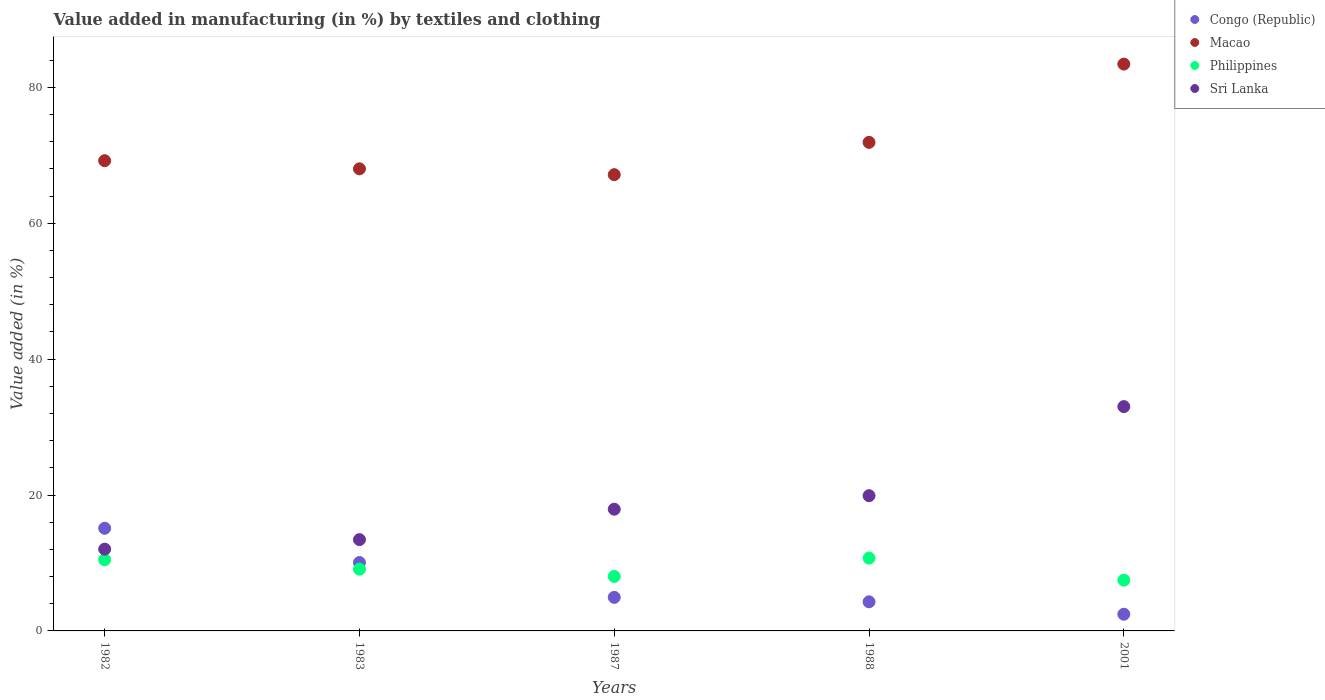Is the number of dotlines equal to the number of legend labels?
Make the answer very short. Yes. What is the percentage of value added in manufacturing by textiles and clothing in Macao in 1988?
Keep it short and to the point. 71.9. Across all years, what is the maximum percentage of value added in manufacturing by textiles and clothing in Sri Lanka?
Keep it short and to the point. 33.01. Across all years, what is the minimum percentage of value added in manufacturing by textiles and clothing in Sri Lanka?
Give a very brief answer. 12.04. In which year was the percentage of value added in manufacturing by textiles and clothing in Congo (Republic) maximum?
Offer a very short reply. 1982. What is the total percentage of value added in manufacturing by textiles and clothing in Macao in the graph?
Ensure brevity in your answer.  359.7. What is the difference between the percentage of value added in manufacturing by textiles and clothing in Philippines in 1983 and that in 2001?
Keep it short and to the point. 1.62. What is the difference between the percentage of value added in manufacturing by textiles and clothing in Congo (Republic) in 1988 and the percentage of value added in manufacturing by textiles and clothing in Philippines in 2001?
Give a very brief answer. -3.19. What is the average percentage of value added in manufacturing by textiles and clothing in Sri Lanka per year?
Keep it short and to the point. 19.26. In the year 1983, what is the difference between the percentage of value added in manufacturing by textiles and clothing in Sri Lanka and percentage of value added in manufacturing by textiles and clothing in Congo (Republic)?
Keep it short and to the point. 3.37. In how many years, is the percentage of value added in manufacturing by textiles and clothing in Sri Lanka greater than 8 %?
Ensure brevity in your answer.  5. What is the ratio of the percentage of value added in manufacturing by textiles and clothing in Macao in 1987 to that in 1988?
Make the answer very short. 0.93. What is the difference between the highest and the second highest percentage of value added in manufacturing by textiles and clothing in Macao?
Offer a very short reply. 11.52. What is the difference between the highest and the lowest percentage of value added in manufacturing by textiles and clothing in Congo (Republic)?
Make the answer very short. 12.65. In how many years, is the percentage of value added in manufacturing by textiles and clothing in Macao greater than the average percentage of value added in manufacturing by textiles and clothing in Macao taken over all years?
Your response must be concise. 1. Is it the case that in every year, the sum of the percentage of value added in manufacturing by textiles and clothing in Congo (Republic) and percentage of value added in manufacturing by textiles and clothing in Macao  is greater than the percentage of value added in manufacturing by textiles and clothing in Sri Lanka?
Ensure brevity in your answer.  Yes. How many years are there in the graph?
Offer a very short reply. 5. What is the difference between two consecutive major ticks on the Y-axis?
Keep it short and to the point. 20. Does the graph contain any zero values?
Your answer should be compact. No. Does the graph contain grids?
Your response must be concise. No. Where does the legend appear in the graph?
Keep it short and to the point. Top right. What is the title of the graph?
Make the answer very short. Value added in manufacturing (in %) by textiles and clothing. What is the label or title of the X-axis?
Give a very brief answer. Years. What is the label or title of the Y-axis?
Ensure brevity in your answer.  Value added (in %). What is the Value added (in %) in Congo (Republic) in 1982?
Your response must be concise. 15.11. What is the Value added (in %) of Macao in 1982?
Your answer should be compact. 69.21. What is the Value added (in %) in Philippines in 1982?
Give a very brief answer. 10.48. What is the Value added (in %) in Sri Lanka in 1982?
Offer a terse response. 12.04. What is the Value added (in %) of Congo (Republic) in 1983?
Provide a short and direct response. 10.07. What is the Value added (in %) of Macao in 1983?
Offer a terse response. 68.01. What is the Value added (in %) in Philippines in 1983?
Offer a very short reply. 9.1. What is the Value added (in %) in Sri Lanka in 1983?
Provide a succinct answer. 13.44. What is the Value added (in %) of Congo (Republic) in 1987?
Make the answer very short. 4.94. What is the Value added (in %) in Macao in 1987?
Offer a terse response. 67.15. What is the Value added (in %) of Philippines in 1987?
Your answer should be compact. 8.02. What is the Value added (in %) in Sri Lanka in 1987?
Offer a terse response. 17.91. What is the Value added (in %) in Congo (Republic) in 1988?
Your answer should be compact. 4.28. What is the Value added (in %) in Macao in 1988?
Make the answer very short. 71.9. What is the Value added (in %) in Philippines in 1988?
Give a very brief answer. 10.72. What is the Value added (in %) of Sri Lanka in 1988?
Your answer should be compact. 19.9. What is the Value added (in %) of Congo (Republic) in 2001?
Provide a succinct answer. 2.46. What is the Value added (in %) of Macao in 2001?
Provide a short and direct response. 83.43. What is the Value added (in %) in Philippines in 2001?
Provide a short and direct response. 7.47. What is the Value added (in %) in Sri Lanka in 2001?
Make the answer very short. 33.01. Across all years, what is the maximum Value added (in %) in Congo (Republic)?
Ensure brevity in your answer.  15.11. Across all years, what is the maximum Value added (in %) in Macao?
Give a very brief answer. 83.43. Across all years, what is the maximum Value added (in %) of Philippines?
Offer a terse response. 10.72. Across all years, what is the maximum Value added (in %) of Sri Lanka?
Your answer should be very brief. 33.01. Across all years, what is the minimum Value added (in %) of Congo (Republic)?
Ensure brevity in your answer.  2.46. Across all years, what is the minimum Value added (in %) of Macao?
Give a very brief answer. 67.15. Across all years, what is the minimum Value added (in %) in Philippines?
Provide a short and direct response. 7.47. Across all years, what is the minimum Value added (in %) in Sri Lanka?
Keep it short and to the point. 12.04. What is the total Value added (in %) of Congo (Republic) in the graph?
Give a very brief answer. 36.86. What is the total Value added (in %) in Macao in the graph?
Offer a very short reply. 359.7. What is the total Value added (in %) of Philippines in the graph?
Offer a terse response. 45.79. What is the total Value added (in %) in Sri Lanka in the graph?
Provide a succinct answer. 96.31. What is the difference between the Value added (in %) of Congo (Republic) in 1982 and that in 1983?
Give a very brief answer. 5.04. What is the difference between the Value added (in %) of Macao in 1982 and that in 1983?
Provide a succinct answer. 1.2. What is the difference between the Value added (in %) of Philippines in 1982 and that in 1983?
Make the answer very short. 1.39. What is the difference between the Value added (in %) in Sri Lanka in 1982 and that in 1983?
Provide a short and direct response. -1.4. What is the difference between the Value added (in %) of Congo (Republic) in 1982 and that in 1987?
Provide a short and direct response. 10.17. What is the difference between the Value added (in %) in Macao in 1982 and that in 1987?
Offer a terse response. 2.06. What is the difference between the Value added (in %) of Philippines in 1982 and that in 1987?
Keep it short and to the point. 2.46. What is the difference between the Value added (in %) of Sri Lanka in 1982 and that in 1987?
Your answer should be very brief. -5.88. What is the difference between the Value added (in %) in Congo (Republic) in 1982 and that in 1988?
Keep it short and to the point. 10.82. What is the difference between the Value added (in %) of Macao in 1982 and that in 1988?
Ensure brevity in your answer.  -2.7. What is the difference between the Value added (in %) of Philippines in 1982 and that in 1988?
Keep it short and to the point. -0.23. What is the difference between the Value added (in %) of Sri Lanka in 1982 and that in 1988?
Your response must be concise. -7.87. What is the difference between the Value added (in %) in Congo (Republic) in 1982 and that in 2001?
Make the answer very short. 12.65. What is the difference between the Value added (in %) in Macao in 1982 and that in 2001?
Offer a very short reply. -14.22. What is the difference between the Value added (in %) in Philippines in 1982 and that in 2001?
Your response must be concise. 3.01. What is the difference between the Value added (in %) of Sri Lanka in 1982 and that in 2001?
Make the answer very short. -20.98. What is the difference between the Value added (in %) of Congo (Republic) in 1983 and that in 1987?
Make the answer very short. 5.13. What is the difference between the Value added (in %) of Macao in 1983 and that in 1987?
Keep it short and to the point. 0.86. What is the difference between the Value added (in %) in Philippines in 1983 and that in 1987?
Keep it short and to the point. 1.07. What is the difference between the Value added (in %) of Sri Lanka in 1983 and that in 1987?
Ensure brevity in your answer.  -4.48. What is the difference between the Value added (in %) in Congo (Republic) in 1983 and that in 1988?
Provide a short and direct response. 5.78. What is the difference between the Value added (in %) of Macao in 1983 and that in 1988?
Ensure brevity in your answer.  -3.89. What is the difference between the Value added (in %) in Philippines in 1983 and that in 1988?
Your response must be concise. -1.62. What is the difference between the Value added (in %) in Sri Lanka in 1983 and that in 1988?
Your response must be concise. -6.47. What is the difference between the Value added (in %) in Congo (Republic) in 1983 and that in 2001?
Your answer should be compact. 7.61. What is the difference between the Value added (in %) of Macao in 1983 and that in 2001?
Provide a short and direct response. -15.41. What is the difference between the Value added (in %) in Philippines in 1983 and that in 2001?
Provide a succinct answer. 1.62. What is the difference between the Value added (in %) in Sri Lanka in 1983 and that in 2001?
Make the answer very short. -19.58. What is the difference between the Value added (in %) in Congo (Republic) in 1987 and that in 1988?
Provide a succinct answer. 0.66. What is the difference between the Value added (in %) of Macao in 1987 and that in 1988?
Offer a terse response. -4.75. What is the difference between the Value added (in %) of Philippines in 1987 and that in 1988?
Offer a very short reply. -2.7. What is the difference between the Value added (in %) of Sri Lanka in 1987 and that in 1988?
Make the answer very short. -1.99. What is the difference between the Value added (in %) of Congo (Republic) in 1987 and that in 2001?
Provide a short and direct response. 2.48. What is the difference between the Value added (in %) in Macao in 1987 and that in 2001?
Your answer should be very brief. -16.28. What is the difference between the Value added (in %) in Philippines in 1987 and that in 2001?
Provide a succinct answer. 0.55. What is the difference between the Value added (in %) of Sri Lanka in 1987 and that in 2001?
Your answer should be compact. -15.1. What is the difference between the Value added (in %) in Congo (Republic) in 1988 and that in 2001?
Make the answer very short. 1.83. What is the difference between the Value added (in %) in Macao in 1988 and that in 2001?
Keep it short and to the point. -11.52. What is the difference between the Value added (in %) of Philippines in 1988 and that in 2001?
Your answer should be very brief. 3.24. What is the difference between the Value added (in %) in Sri Lanka in 1988 and that in 2001?
Your response must be concise. -13.11. What is the difference between the Value added (in %) in Congo (Republic) in 1982 and the Value added (in %) in Macao in 1983?
Provide a succinct answer. -52.9. What is the difference between the Value added (in %) of Congo (Republic) in 1982 and the Value added (in %) of Philippines in 1983?
Keep it short and to the point. 6.01. What is the difference between the Value added (in %) in Congo (Republic) in 1982 and the Value added (in %) in Sri Lanka in 1983?
Your answer should be compact. 1.67. What is the difference between the Value added (in %) of Macao in 1982 and the Value added (in %) of Philippines in 1983?
Give a very brief answer. 60.11. What is the difference between the Value added (in %) of Macao in 1982 and the Value added (in %) of Sri Lanka in 1983?
Give a very brief answer. 55.77. What is the difference between the Value added (in %) in Philippines in 1982 and the Value added (in %) in Sri Lanka in 1983?
Keep it short and to the point. -2.95. What is the difference between the Value added (in %) of Congo (Republic) in 1982 and the Value added (in %) of Macao in 1987?
Make the answer very short. -52.04. What is the difference between the Value added (in %) of Congo (Republic) in 1982 and the Value added (in %) of Philippines in 1987?
Give a very brief answer. 7.08. What is the difference between the Value added (in %) of Congo (Republic) in 1982 and the Value added (in %) of Sri Lanka in 1987?
Provide a short and direct response. -2.81. What is the difference between the Value added (in %) in Macao in 1982 and the Value added (in %) in Philippines in 1987?
Offer a very short reply. 61.19. What is the difference between the Value added (in %) of Macao in 1982 and the Value added (in %) of Sri Lanka in 1987?
Provide a succinct answer. 51.29. What is the difference between the Value added (in %) of Philippines in 1982 and the Value added (in %) of Sri Lanka in 1987?
Provide a succinct answer. -7.43. What is the difference between the Value added (in %) in Congo (Republic) in 1982 and the Value added (in %) in Macao in 1988?
Give a very brief answer. -56.8. What is the difference between the Value added (in %) of Congo (Republic) in 1982 and the Value added (in %) of Philippines in 1988?
Give a very brief answer. 4.39. What is the difference between the Value added (in %) in Congo (Republic) in 1982 and the Value added (in %) in Sri Lanka in 1988?
Offer a terse response. -4.8. What is the difference between the Value added (in %) in Macao in 1982 and the Value added (in %) in Philippines in 1988?
Offer a terse response. 58.49. What is the difference between the Value added (in %) of Macao in 1982 and the Value added (in %) of Sri Lanka in 1988?
Your answer should be compact. 49.3. What is the difference between the Value added (in %) of Philippines in 1982 and the Value added (in %) of Sri Lanka in 1988?
Your answer should be very brief. -9.42. What is the difference between the Value added (in %) of Congo (Republic) in 1982 and the Value added (in %) of Macao in 2001?
Ensure brevity in your answer.  -68.32. What is the difference between the Value added (in %) in Congo (Republic) in 1982 and the Value added (in %) in Philippines in 2001?
Provide a succinct answer. 7.63. What is the difference between the Value added (in %) in Congo (Republic) in 1982 and the Value added (in %) in Sri Lanka in 2001?
Your answer should be compact. -17.91. What is the difference between the Value added (in %) of Macao in 1982 and the Value added (in %) of Philippines in 2001?
Offer a very short reply. 61.73. What is the difference between the Value added (in %) in Macao in 1982 and the Value added (in %) in Sri Lanka in 2001?
Ensure brevity in your answer.  36.19. What is the difference between the Value added (in %) in Philippines in 1982 and the Value added (in %) in Sri Lanka in 2001?
Your response must be concise. -22.53. What is the difference between the Value added (in %) of Congo (Republic) in 1983 and the Value added (in %) of Macao in 1987?
Keep it short and to the point. -57.08. What is the difference between the Value added (in %) of Congo (Republic) in 1983 and the Value added (in %) of Philippines in 1987?
Give a very brief answer. 2.04. What is the difference between the Value added (in %) in Congo (Republic) in 1983 and the Value added (in %) in Sri Lanka in 1987?
Provide a short and direct response. -7.85. What is the difference between the Value added (in %) of Macao in 1983 and the Value added (in %) of Philippines in 1987?
Ensure brevity in your answer.  59.99. What is the difference between the Value added (in %) in Macao in 1983 and the Value added (in %) in Sri Lanka in 1987?
Your response must be concise. 50.1. What is the difference between the Value added (in %) in Philippines in 1983 and the Value added (in %) in Sri Lanka in 1987?
Provide a short and direct response. -8.82. What is the difference between the Value added (in %) in Congo (Republic) in 1983 and the Value added (in %) in Macao in 1988?
Provide a succinct answer. -61.84. What is the difference between the Value added (in %) in Congo (Republic) in 1983 and the Value added (in %) in Philippines in 1988?
Provide a short and direct response. -0.65. What is the difference between the Value added (in %) of Congo (Republic) in 1983 and the Value added (in %) of Sri Lanka in 1988?
Give a very brief answer. -9.84. What is the difference between the Value added (in %) of Macao in 1983 and the Value added (in %) of Philippines in 1988?
Provide a succinct answer. 57.29. What is the difference between the Value added (in %) in Macao in 1983 and the Value added (in %) in Sri Lanka in 1988?
Make the answer very short. 48.11. What is the difference between the Value added (in %) in Philippines in 1983 and the Value added (in %) in Sri Lanka in 1988?
Your response must be concise. -10.81. What is the difference between the Value added (in %) in Congo (Republic) in 1983 and the Value added (in %) in Macao in 2001?
Give a very brief answer. -73.36. What is the difference between the Value added (in %) of Congo (Republic) in 1983 and the Value added (in %) of Philippines in 2001?
Offer a terse response. 2.59. What is the difference between the Value added (in %) of Congo (Republic) in 1983 and the Value added (in %) of Sri Lanka in 2001?
Give a very brief answer. -22.95. What is the difference between the Value added (in %) in Macao in 1983 and the Value added (in %) in Philippines in 2001?
Your answer should be compact. 60.54. What is the difference between the Value added (in %) of Macao in 1983 and the Value added (in %) of Sri Lanka in 2001?
Provide a short and direct response. 35. What is the difference between the Value added (in %) of Philippines in 1983 and the Value added (in %) of Sri Lanka in 2001?
Make the answer very short. -23.92. What is the difference between the Value added (in %) in Congo (Republic) in 1987 and the Value added (in %) in Macao in 1988?
Make the answer very short. -66.96. What is the difference between the Value added (in %) of Congo (Republic) in 1987 and the Value added (in %) of Philippines in 1988?
Offer a very short reply. -5.78. What is the difference between the Value added (in %) of Congo (Republic) in 1987 and the Value added (in %) of Sri Lanka in 1988?
Your answer should be very brief. -14.96. What is the difference between the Value added (in %) of Macao in 1987 and the Value added (in %) of Philippines in 1988?
Keep it short and to the point. 56.43. What is the difference between the Value added (in %) in Macao in 1987 and the Value added (in %) in Sri Lanka in 1988?
Provide a succinct answer. 47.25. What is the difference between the Value added (in %) of Philippines in 1987 and the Value added (in %) of Sri Lanka in 1988?
Your response must be concise. -11.88. What is the difference between the Value added (in %) in Congo (Republic) in 1987 and the Value added (in %) in Macao in 2001?
Keep it short and to the point. -78.49. What is the difference between the Value added (in %) in Congo (Republic) in 1987 and the Value added (in %) in Philippines in 2001?
Offer a terse response. -2.53. What is the difference between the Value added (in %) of Congo (Republic) in 1987 and the Value added (in %) of Sri Lanka in 2001?
Give a very brief answer. -28.07. What is the difference between the Value added (in %) of Macao in 1987 and the Value added (in %) of Philippines in 2001?
Your answer should be very brief. 59.68. What is the difference between the Value added (in %) of Macao in 1987 and the Value added (in %) of Sri Lanka in 2001?
Provide a short and direct response. 34.14. What is the difference between the Value added (in %) in Philippines in 1987 and the Value added (in %) in Sri Lanka in 2001?
Give a very brief answer. -24.99. What is the difference between the Value added (in %) of Congo (Republic) in 1988 and the Value added (in %) of Macao in 2001?
Give a very brief answer. -79.14. What is the difference between the Value added (in %) of Congo (Republic) in 1988 and the Value added (in %) of Philippines in 2001?
Give a very brief answer. -3.19. What is the difference between the Value added (in %) in Congo (Republic) in 1988 and the Value added (in %) in Sri Lanka in 2001?
Keep it short and to the point. -28.73. What is the difference between the Value added (in %) of Macao in 1988 and the Value added (in %) of Philippines in 2001?
Make the answer very short. 64.43. What is the difference between the Value added (in %) in Macao in 1988 and the Value added (in %) in Sri Lanka in 2001?
Provide a short and direct response. 38.89. What is the difference between the Value added (in %) in Philippines in 1988 and the Value added (in %) in Sri Lanka in 2001?
Your answer should be very brief. -22.3. What is the average Value added (in %) in Congo (Republic) per year?
Your response must be concise. 7.37. What is the average Value added (in %) in Macao per year?
Your answer should be compact. 71.94. What is the average Value added (in %) of Philippines per year?
Keep it short and to the point. 9.16. What is the average Value added (in %) in Sri Lanka per year?
Give a very brief answer. 19.26. In the year 1982, what is the difference between the Value added (in %) of Congo (Republic) and Value added (in %) of Macao?
Provide a succinct answer. -54.1. In the year 1982, what is the difference between the Value added (in %) of Congo (Republic) and Value added (in %) of Philippines?
Make the answer very short. 4.62. In the year 1982, what is the difference between the Value added (in %) of Congo (Republic) and Value added (in %) of Sri Lanka?
Ensure brevity in your answer.  3.07. In the year 1982, what is the difference between the Value added (in %) in Macao and Value added (in %) in Philippines?
Your answer should be very brief. 58.72. In the year 1982, what is the difference between the Value added (in %) in Macao and Value added (in %) in Sri Lanka?
Provide a succinct answer. 57.17. In the year 1982, what is the difference between the Value added (in %) of Philippines and Value added (in %) of Sri Lanka?
Make the answer very short. -1.55. In the year 1983, what is the difference between the Value added (in %) of Congo (Republic) and Value added (in %) of Macao?
Give a very brief answer. -57.94. In the year 1983, what is the difference between the Value added (in %) in Congo (Republic) and Value added (in %) in Philippines?
Make the answer very short. 0.97. In the year 1983, what is the difference between the Value added (in %) of Congo (Republic) and Value added (in %) of Sri Lanka?
Provide a short and direct response. -3.37. In the year 1983, what is the difference between the Value added (in %) in Macao and Value added (in %) in Philippines?
Your answer should be compact. 58.91. In the year 1983, what is the difference between the Value added (in %) in Macao and Value added (in %) in Sri Lanka?
Provide a short and direct response. 54.57. In the year 1983, what is the difference between the Value added (in %) in Philippines and Value added (in %) in Sri Lanka?
Your response must be concise. -4.34. In the year 1987, what is the difference between the Value added (in %) of Congo (Republic) and Value added (in %) of Macao?
Offer a very short reply. -62.21. In the year 1987, what is the difference between the Value added (in %) of Congo (Republic) and Value added (in %) of Philippines?
Offer a terse response. -3.08. In the year 1987, what is the difference between the Value added (in %) of Congo (Republic) and Value added (in %) of Sri Lanka?
Your answer should be very brief. -12.97. In the year 1987, what is the difference between the Value added (in %) of Macao and Value added (in %) of Philippines?
Give a very brief answer. 59.13. In the year 1987, what is the difference between the Value added (in %) in Macao and Value added (in %) in Sri Lanka?
Give a very brief answer. 49.24. In the year 1987, what is the difference between the Value added (in %) in Philippines and Value added (in %) in Sri Lanka?
Your answer should be compact. -9.89. In the year 1988, what is the difference between the Value added (in %) in Congo (Republic) and Value added (in %) in Macao?
Make the answer very short. -67.62. In the year 1988, what is the difference between the Value added (in %) of Congo (Republic) and Value added (in %) of Philippines?
Offer a terse response. -6.43. In the year 1988, what is the difference between the Value added (in %) of Congo (Republic) and Value added (in %) of Sri Lanka?
Your answer should be very brief. -15.62. In the year 1988, what is the difference between the Value added (in %) of Macao and Value added (in %) of Philippines?
Offer a terse response. 61.19. In the year 1988, what is the difference between the Value added (in %) of Macao and Value added (in %) of Sri Lanka?
Offer a terse response. 52. In the year 1988, what is the difference between the Value added (in %) of Philippines and Value added (in %) of Sri Lanka?
Offer a terse response. -9.19. In the year 2001, what is the difference between the Value added (in %) in Congo (Republic) and Value added (in %) in Macao?
Give a very brief answer. -80.97. In the year 2001, what is the difference between the Value added (in %) in Congo (Republic) and Value added (in %) in Philippines?
Your answer should be very brief. -5.01. In the year 2001, what is the difference between the Value added (in %) of Congo (Republic) and Value added (in %) of Sri Lanka?
Offer a very short reply. -30.56. In the year 2001, what is the difference between the Value added (in %) in Macao and Value added (in %) in Philippines?
Offer a terse response. 75.95. In the year 2001, what is the difference between the Value added (in %) of Macao and Value added (in %) of Sri Lanka?
Your response must be concise. 50.41. In the year 2001, what is the difference between the Value added (in %) of Philippines and Value added (in %) of Sri Lanka?
Your answer should be compact. -25.54. What is the ratio of the Value added (in %) of Congo (Republic) in 1982 to that in 1983?
Provide a short and direct response. 1.5. What is the ratio of the Value added (in %) in Macao in 1982 to that in 1983?
Provide a succinct answer. 1.02. What is the ratio of the Value added (in %) in Philippines in 1982 to that in 1983?
Make the answer very short. 1.15. What is the ratio of the Value added (in %) of Sri Lanka in 1982 to that in 1983?
Make the answer very short. 0.9. What is the ratio of the Value added (in %) of Congo (Republic) in 1982 to that in 1987?
Give a very brief answer. 3.06. What is the ratio of the Value added (in %) of Macao in 1982 to that in 1987?
Provide a short and direct response. 1.03. What is the ratio of the Value added (in %) in Philippines in 1982 to that in 1987?
Make the answer very short. 1.31. What is the ratio of the Value added (in %) of Sri Lanka in 1982 to that in 1987?
Offer a very short reply. 0.67. What is the ratio of the Value added (in %) of Congo (Republic) in 1982 to that in 1988?
Offer a very short reply. 3.53. What is the ratio of the Value added (in %) in Macao in 1982 to that in 1988?
Your answer should be very brief. 0.96. What is the ratio of the Value added (in %) in Philippines in 1982 to that in 1988?
Keep it short and to the point. 0.98. What is the ratio of the Value added (in %) in Sri Lanka in 1982 to that in 1988?
Your answer should be compact. 0.6. What is the ratio of the Value added (in %) in Congo (Republic) in 1982 to that in 2001?
Your response must be concise. 6.15. What is the ratio of the Value added (in %) in Macao in 1982 to that in 2001?
Your answer should be very brief. 0.83. What is the ratio of the Value added (in %) in Philippines in 1982 to that in 2001?
Provide a short and direct response. 1.4. What is the ratio of the Value added (in %) in Sri Lanka in 1982 to that in 2001?
Your answer should be very brief. 0.36. What is the ratio of the Value added (in %) in Congo (Republic) in 1983 to that in 1987?
Offer a very short reply. 2.04. What is the ratio of the Value added (in %) in Macao in 1983 to that in 1987?
Offer a very short reply. 1.01. What is the ratio of the Value added (in %) in Philippines in 1983 to that in 1987?
Provide a short and direct response. 1.13. What is the ratio of the Value added (in %) of Sri Lanka in 1983 to that in 1987?
Provide a short and direct response. 0.75. What is the ratio of the Value added (in %) in Congo (Republic) in 1983 to that in 1988?
Provide a short and direct response. 2.35. What is the ratio of the Value added (in %) in Macao in 1983 to that in 1988?
Ensure brevity in your answer.  0.95. What is the ratio of the Value added (in %) in Philippines in 1983 to that in 1988?
Offer a very short reply. 0.85. What is the ratio of the Value added (in %) in Sri Lanka in 1983 to that in 1988?
Offer a terse response. 0.68. What is the ratio of the Value added (in %) in Congo (Republic) in 1983 to that in 2001?
Give a very brief answer. 4.09. What is the ratio of the Value added (in %) in Macao in 1983 to that in 2001?
Offer a very short reply. 0.82. What is the ratio of the Value added (in %) in Philippines in 1983 to that in 2001?
Offer a very short reply. 1.22. What is the ratio of the Value added (in %) in Sri Lanka in 1983 to that in 2001?
Provide a succinct answer. 0.41. What is the ratio of the Value added (in %) in Congo (Republic) in 1987 to that in 1988?
Keep it short and to the point. 1.15. What is the ratio of the Value added (in %) in Macao in 1987 to that in 1988?
Your answer should be very brief. 0.93. What is the ratio of the Value added (in %) in Philippines in 1987 to that in 1988?
Your answer should be compact. 0.75. What is the ratio of the Value added (in %) in Congo (Republic) in 1987 to that in 2001?
Provide a succinct answer. 2.01. What is the ratio of the Value added (in %) of Macao in 1987 to that in 2001?
Your answer should be compact. 0.8. What is the ratio of the Value added (in %) in Philippines in 1987 to that in 2001?
Give a very brief answer. 1.07. What is the ratio of the Value added (in %) in Sri Lanka in 1987 to that in 2001?
Provide a succinct answer. 0.54. What is the ratio of the Value added (in %) in Congo (Republic) in 1988 to that in 2001?
Provide a succinct answer. 1.74. What is the ratio of the Value added (in %) of Macao in 1988 to that in 2001?
Keep it short and to the point. 0.86. What is the ratio of the Value added (in %) in Philippines in 1988 to that in 2001?
Offer a terse response. 1.43. What is the ratio of the Value added (in %) in Sri Lanka in 1988 to that in 2001?
Your answer should be very brief. 0.6. What is the difference between the highest and the second highest Value added (in %) in Congo (Republic)?
Your response must be concise. 5.04. What is the difference between the highest and the second highest Value added (in %) of Macao?
Offer a very short reply. 11.52. What is the difference between the highest and the second highest Value added (in %) of Philippines?
Your answer should be very brief. 0.23. What is the difference between the highest and the second highest Value added (in %) in Sri Lanka?
Ensure brevity in your answer.  13.11. What is the difference between the highest and the lowest Value added (in %) of Congo (Republic)?
Your response must be concise. 12.65. What is the difference between the highest and the lowest Value added (in %) in Macao?
Offer a very short reply. 16.28. What is the difference between the highest and the lowest Value added (in %) in Philippines?
Offer a terse response. 3.24. What is the difference between the highest and the lowest Value added (in %) of Sri Lanka?
Your answer should be very brief. 20.98. 